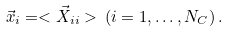<formula> <loc_0><loc_0><loc_500><loc_500>\vec { x } _ { i } = < \vec { X } _ { i i } > \, ( i = 1 , \dots , N _ { C } ) \, .</formula> 